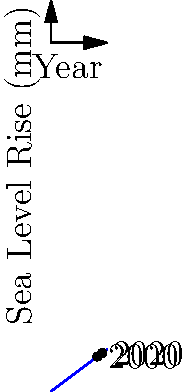As a volunteer witnessing the impacts of climate change, you're analyzing sea level rise data. The graph shows historical sea level rise from 2000 to 2020. Calculate the average rate of sea level rise per year during this period. To calculate the average rate of sea level rise per year:

1. Identify two points on the graph:
   - Year 2000: (200, 150) mm
   - Year 2020: (220, 165) mm

2. Calculate the total rise in sea level:
   $165 \text{ mm} - 150 \text{ mm} = 15 \text{ mm}$

3. Determine the time period:
   $2020 - 2000 = 20 \text{ years}$

4. Calculate the average rate of rise per year:
   $$\text{Rate} = \frac{\text{Total rise}}{\text{Time period}} = \frac{15 \text{ mm}}{20 \text{ years}} = 0.75 \text{ mm/year}$$

Therefore, the average rate of sea level rise is 0.75 mm per year.
Answer: 0.75 mm/year 